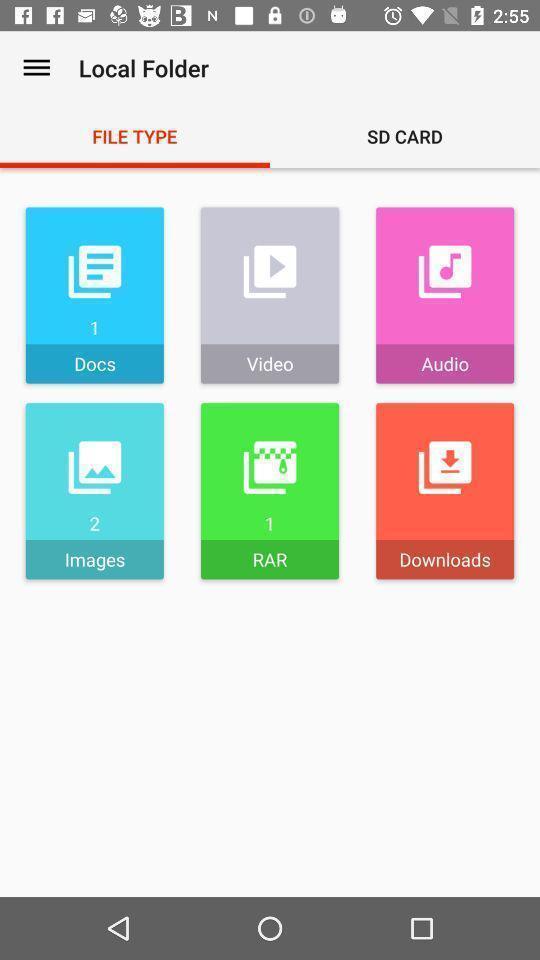Please provide a description for this image. Various file formats page displayed in a explorer app. 